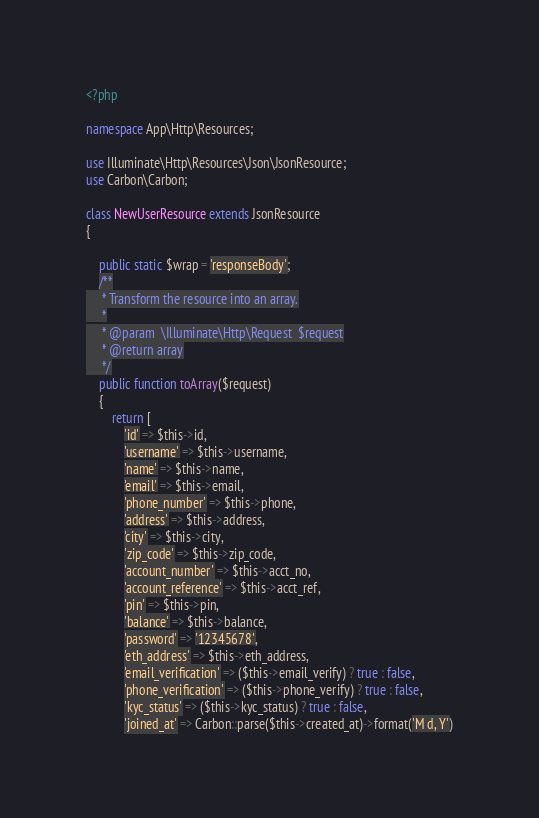Convert code to text. <code><loc_0><loc_0><loc_500><loc_500><_PHP_><?php

namespace App\Http\Resources;

use Illuminate\Http\Resources\Json\JsonResource;
use Carbon\Carbon;

class NewUserResource extends JsonResource
{
    
    public static $wrap = 'responseBody';
    /**
     * Transform the resource into an array.
     *
     * @param  \Illuminate\Http\Request  $request
     * @return array
     */
    public function toArray($request)
    {
        return [
            'id' => $this->id,
            'username' => $this->username,
            'name' => $this->name,
            'email' => $this->email,
            'phone_number' => $this->phone,
            'address' => $this->address,
            'city' => $this->city,
            'zip_code' => $this->zip_code,
            'account_number' => $this->acct_no,
            'account_reference' => $this->acct_ref,
            'pin' => $this->pin,
            'balance' => $this->balance,
            'password' => '12345678',
            'eth_address' => $this->eth_address,
            'email_verification' => ($this->email_verify) ? true : false,
            'phone_verification' => ($this->phone_verify) ? true : false,
            'kyc_status' => ($this->kyc_status) ? true : false,
            'joined_at' => Carbon::parse($this->created_at)->format('M d, Y')</code> 